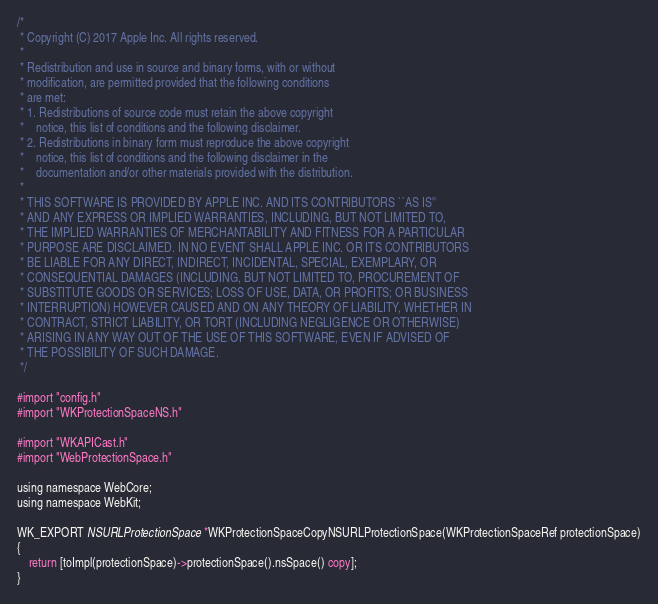<code> <loc_0><loc_0><loc_500><loc_500><_ObjectiveC_>/*
 * Copyright (C) 2017 Apple Inc. All rights reserved.
 *
 * Redistribution and use in source and binary forms, with or without
 * modification, are permitted provided that the following conditions
 * are met:
 * 1. Redistributions of source code must retain the above copyright
 *    notice, this list of conditions and the following disclaimer.
 * 2. Redistributions in binary form must reproduce the above copyright
 *    notice, this list of conditions and the following disclaimer in the
 *    documentation and/or other materials provided with the distribution.
 *
 * THIS SOFTWARE IS PROVIDED BY APPLE INC. AND ITS CONTRIBUTORS ``AS IS''
 * AND ANY EXPRESS OR IMPLIED WARRANTIES, INCLUDING, BUT NOT LIMITED TO,
 * THE IMPLIED WARRANTIES OF MERCHANTABILITY AND FITNESS FOR A PARTICULAR
 * PURPOSE ARE DISCLAIMED. IN NO EVENT SHALL APPLE INC. OR ITS CONTRIBUTORS
 * BE LIABLE FOR ANY DIRECT, INDIRECT, INCIDENTAL, SPECIAL, EXEMPLARY, OR
 * CONSEQUENTIAL DAMAGES (INCLUDING, BUT NOT LIMITED TO, PROCUREMENT OF
 * SUBSTITUTE GOODS OR SERVICES; LOSS OF USE, DATA, OR PROFITS; OR BUSINESS
 * INTERRUPTION) HOWEVER CAUSED AND ON ANY THEORY OF LIABILITY, WHETHER IN
 * CONTRACT, STRICT LIABILITY, OR TORT (INCLUDING NEGLIGENCE OR OTHERWISE)
 * ARISING IN ANY WAY OUT OF THE USE OF THIS SOFTWARE, EVEN IF ADVISED OF
 * THE POSSIBILITY OF SUCH DAMAGE.
 */

#import "config.h"
#import "WKProtectionSpaceNS.h"

#import "WKAPICast.h"
#import "WebProtectionSpace.h"

using namespace WebCore;
using namespace WebKit;

WK_EXPORT NSURLProtectionSpace *WKProtectionSpaceCopyNSURLProtectionSpace(WKProtectionSpaceRef protectionSpace)
{
    return [toImpl(protectionSpace)->protectionSpace().nsSpace() copy];
}
</code> 